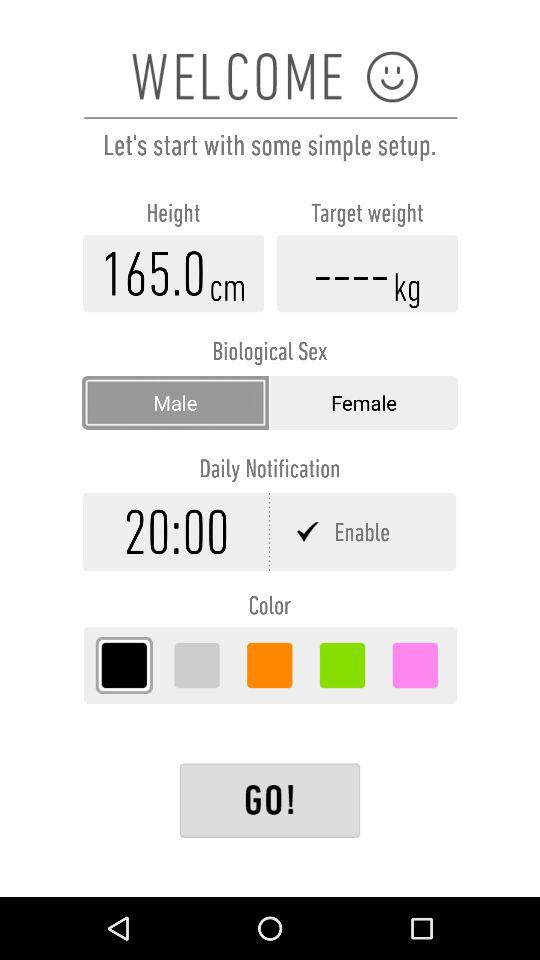What is the height? The height is 165.0 cm. 